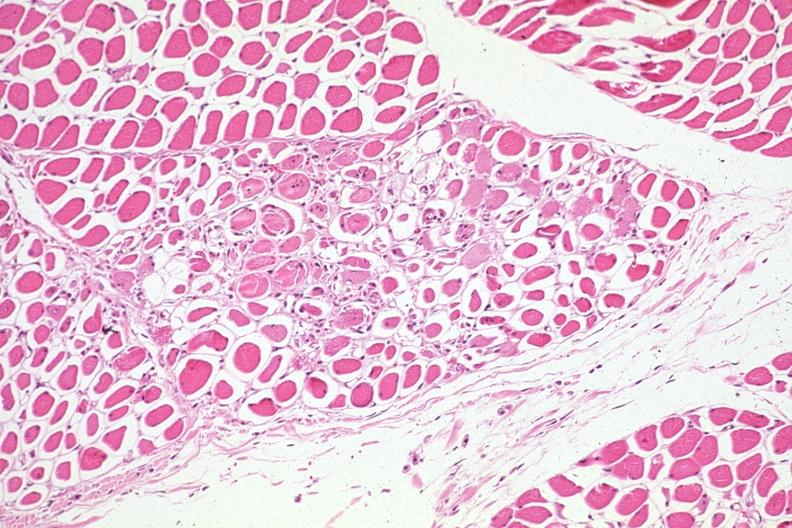what does this image show?
Answer the question using a single word or phrase. Lesions easily seen treated myelogenous leukemia complicated by infection and dic 